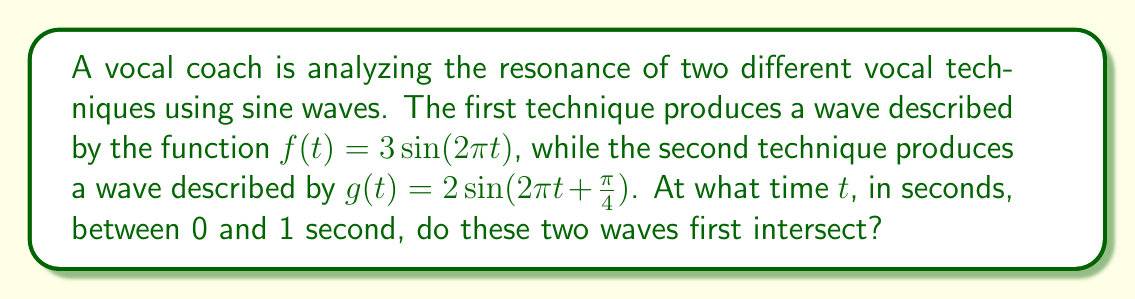Solve this math problem. To find the intersection point, we need to solve the equation:

$f(t) = g(t)$

$3\sin(2\pi t) = 2\sin(2\pi t + \frac{\pi}{4})$

Let's approach this step-by-step:

1) First, we can use the sine addition formula:
   $\sin(A + B) = \sin A \cos B + \cos A \sin B$

2) Applying this to the right side of our equation:
   $2\sin(2\pi t + \frac{\pi}{4}) = 2[\sin(2\pi t)\cos(\frac{\pi}{4}) + \cos(2\pi t)\sin(\frac{\pi}{4})]$

3) We know that $\cos(\frac{\pi}{4}) = \sin(\frac{\pi}{4}) = \frac{\sqrt{2}}{2}$, so:
   $2[\sin(2\pi t)\frac{\sqrt{2}}{2} + \cos(2\pi t)\frac{\sqrt{2}}{2}] = \sqrt{2}[\sin(2\pi t) + \cos(2\pi t)]$

4) Now our equation looks like:
   $3\sin(2\pi t) = \sqrt{2}[\sin(2\pi t) + \cos(2\pi t)]$

5) Rearranging terms:
   $3\sin(2\pi t) - \sqrt{2}\sin(2\pi t) = \sqrt{2}\cos(2\pi t)$
   $(3-\sqrt{2})\sin(2\pi t) = \sqrt{2}\cos(2\pi t)$

6) Dividing both sides by $\sqrt{2}$:
   $\frac{3-\sqrt{2}}{\sqrt{2}}\sin(2\pi t) = \cos(2\pi t)$

7) This is in the form of $\tan(2\pi t) = \frac{\sqrt{2}}{3-\sqrt{2}}$

8) Taking the arctangent of both sides:
   $2\pi t = \arctan(\frac{\sqrt{2}}{3-\sqrt{2}})$

9) Solving for $t$:
   $t = \frac{1}{2\pi}\arctan(\frac{\sqrt{2}}{3-\sqrt{2}}) \approx 0.1057$ seconds

This is the first intersection point between 0 and 1 second.
Answer: $\frac{1}{2\pi}\arctan(\frac{\sqrt{2}}{3-\sqrt{2}})$ seconds 